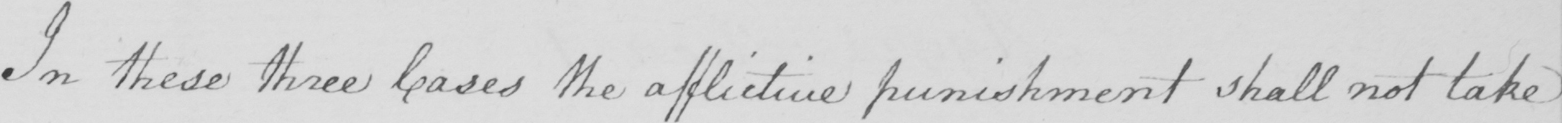Can you tell me what this handwritten text says? In these three cases the afflictive punishment shall not take 